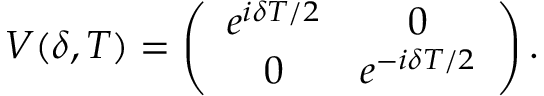<formula> <loc_0><loc_0><loc_500><loc_500>V ( \delta , T ) = \left ( \begin{array} { c c } { e ^ { i \delta T / 2 } } & { 0 } \\ { 0 } & { e ^ { - i \delta T / 2 } } \end{array} \right ) .</formula> 